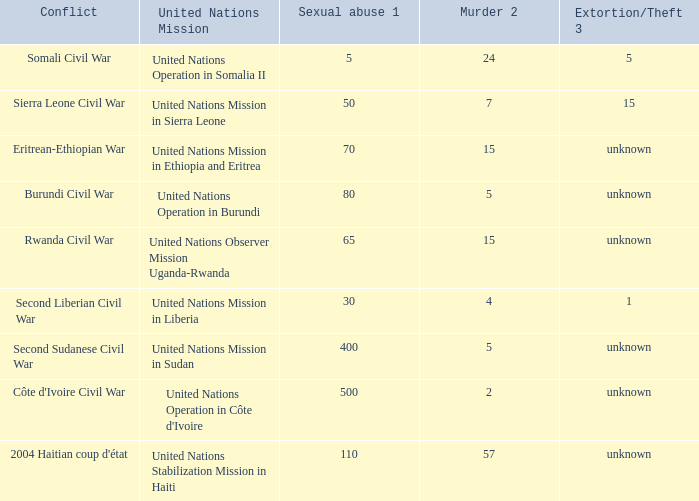What is the sexual abuse rate where the conflict is the Burundi Civil War? 80.0. 